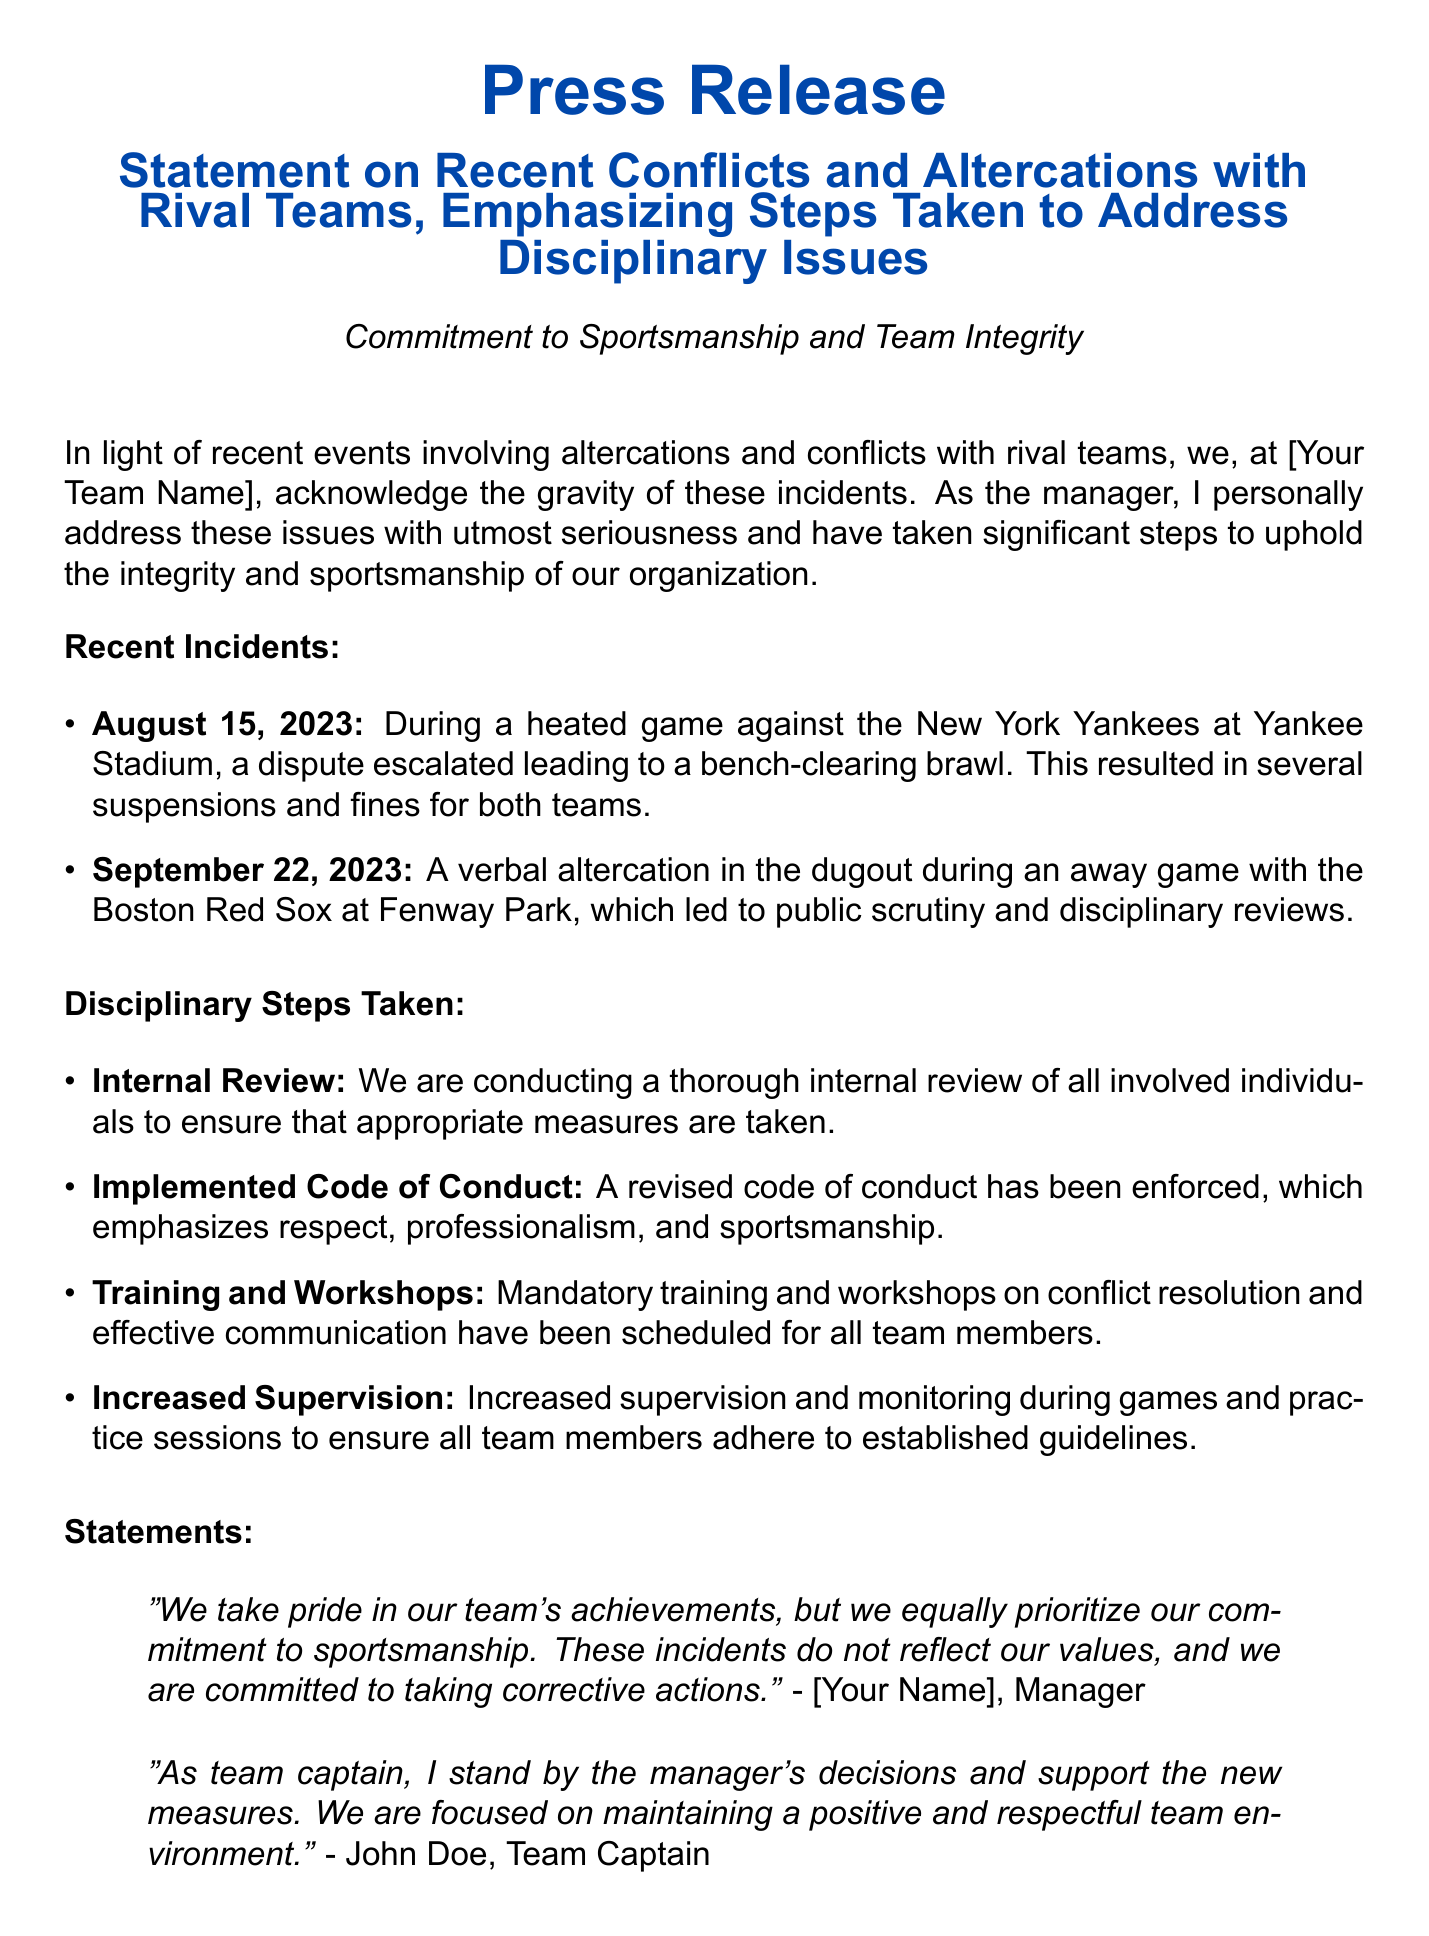What was the date of the altercation against the New York Yankees? The altercation against the New York Yankees occurred on August 15, 2023.
Answer: August 15, 2023 How many suspensions resulted from the August 15 incident? The statement mentions that there were several suspensions due to the incident but does not specify a number.
Answer: Several What is one of the disciplinary steps taken by the team? The document lists multiple disciplinary steps, such as conducting an internal review, enforcing a code of conduct, offering training workshops, and increasing supervision.
Answer: Internal review Who addressed the need for conflict resolution training? The press release indicates that mandatory training and workshops on conflict resolution have been scheduled for all team members, but does not specify who initiated this.
Answer: Not specified What incident occurred on September 22, 2023? The incident on September 22, 2023 involved a verbal altercation in the dugout during a game with the Boston Red Sox.
Answer: Verbal altercation What are the team's priorities according to the manager's statement? The manager's statement emphasizes the importance of sportsmanship and commitment to corrective actions.
Answer: Sportsmanship Which player supports the manager's new measures? John Doe, the Team Captain, expresses his support for the manager's decisions.
Answer: John Doe What was the team's reaction to the recent incidents? The press release describes regret for any negative impact caused by the incidents and reaffirms the commitment to high standards of discipline.
Answer: Regret 